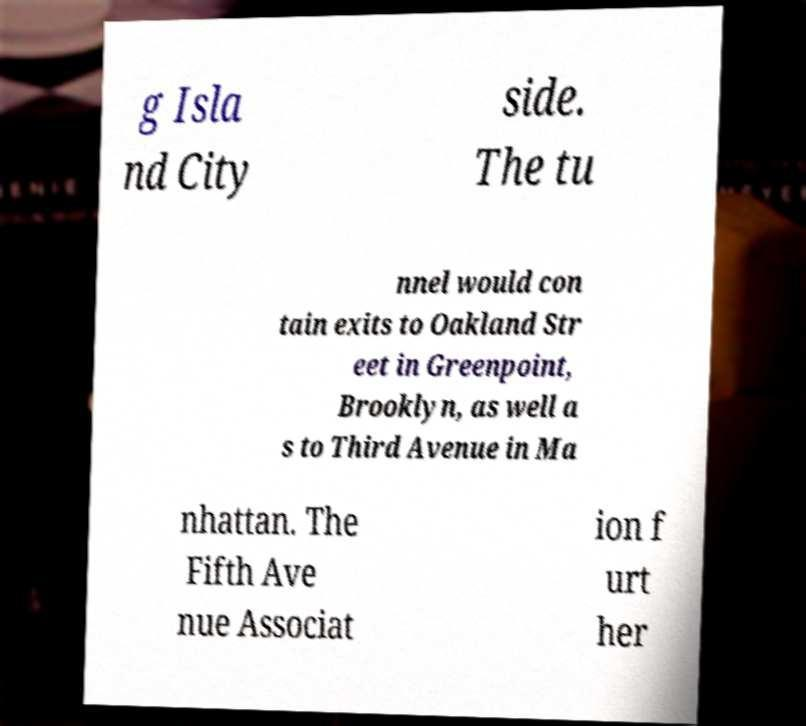Can you read and provide the text displayed in the image?This photo seems to have some interesting text. Can you extract and type it out for me? g Isla nd City side. The tu nnel would con tain exits to Oakland Str eet in Greenpoint, Brooklyn, as well a s to Third Avenue in Ma nhattan. The Fifth Ave nue Associat ion f urt her 